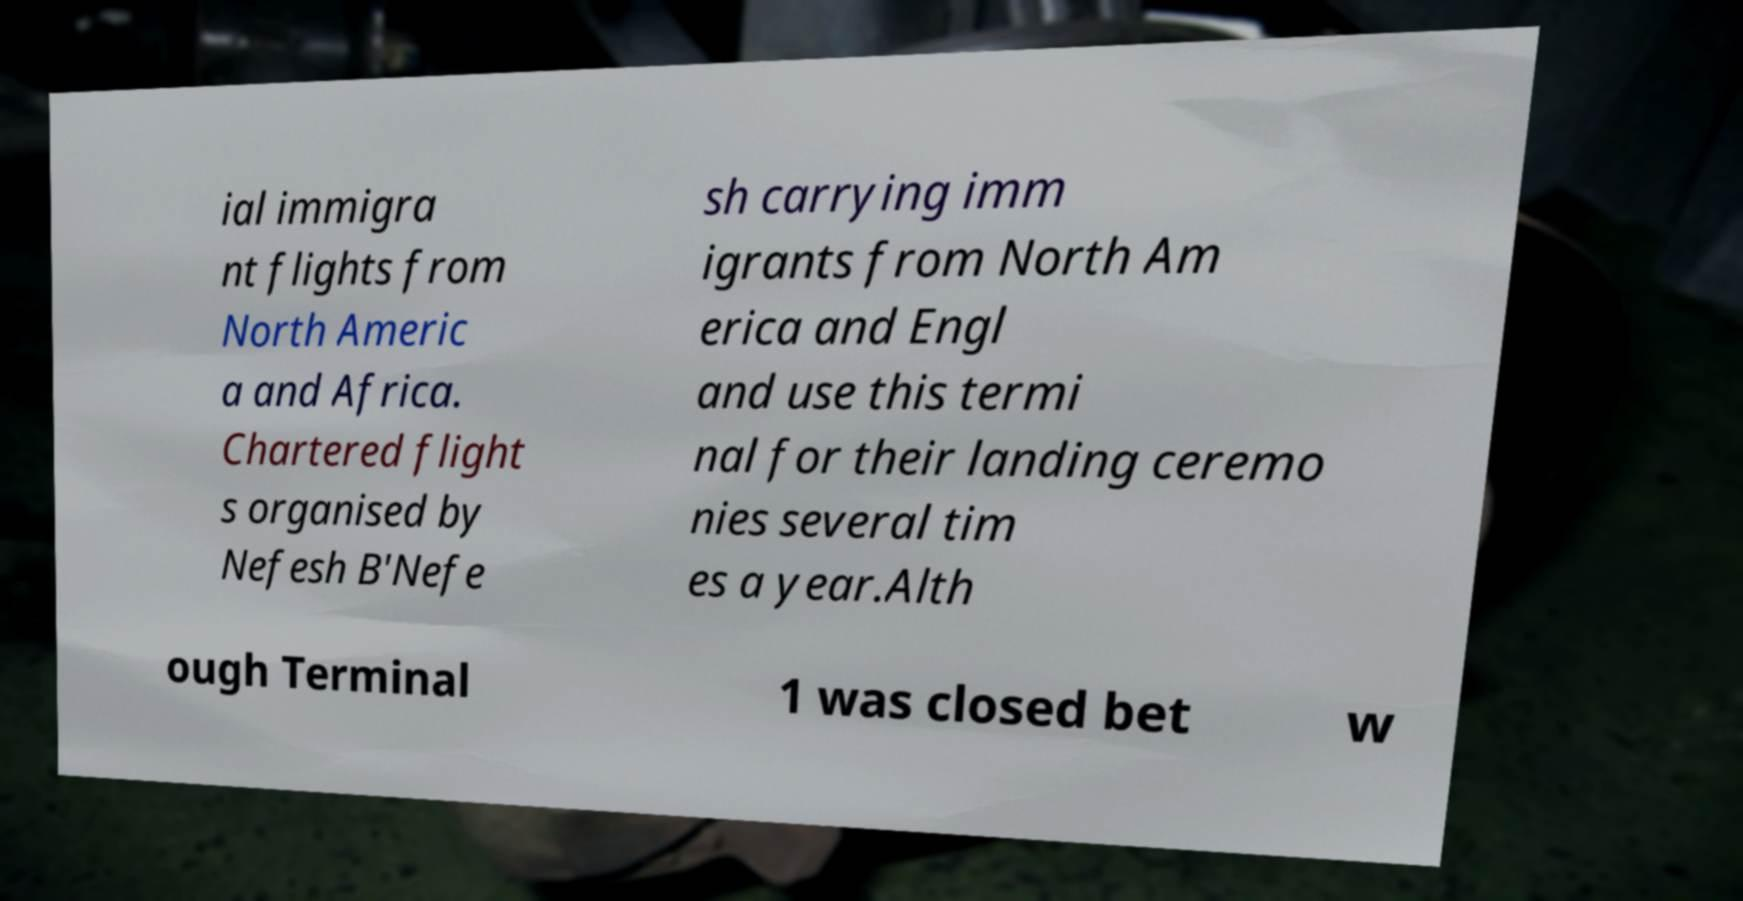Could you extract and type out the text from this image? ial immigra nt flights from North Americ a and Africa. Chartered flight s organised by Nefesh B'Nefe sh carrying imm igrants from North Am erica and Engl and use this termi nal for their landing ceremo nies several tim es a year.Alth ough Terminal 1 was closed bet w 